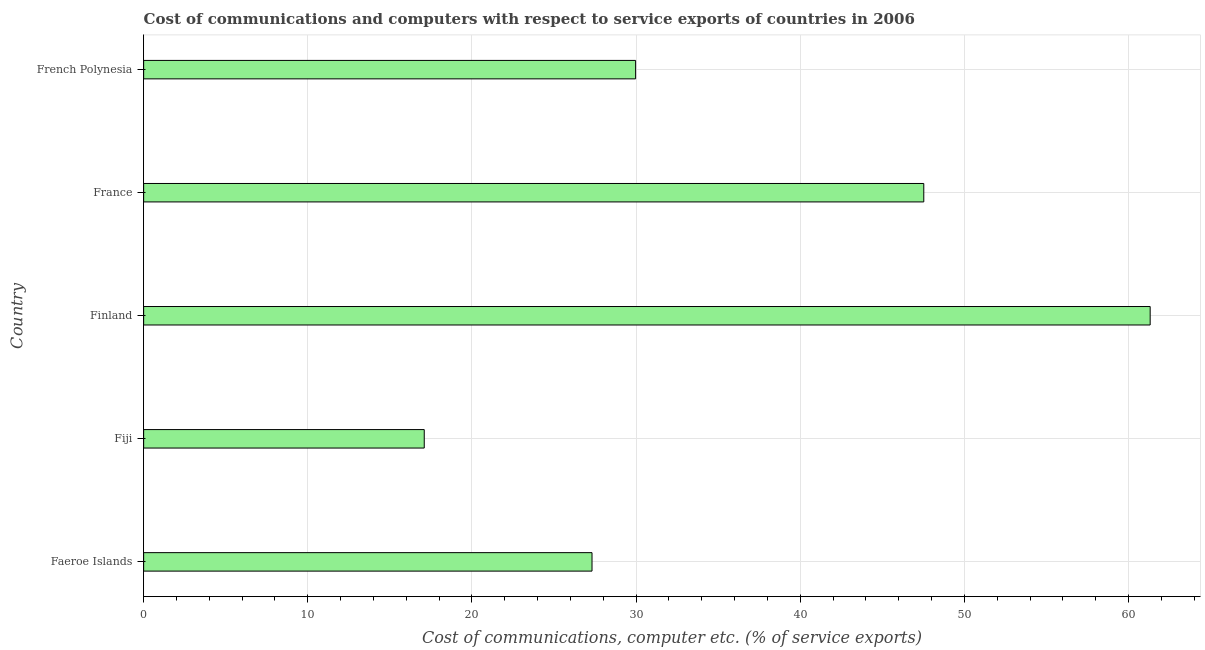Does the graph contain any zero values?
Your response must be concise. No. Does the graph contain grids?
Your response must be concise. Yes. What is the title of the graph?
Provide a succinct answer. Cost of communications and computers with respect to service exports of countries in 2006. What is the label or title of the X-axis?
Provide a succinct answer. Cost of communications, computer etc. (% of service exports). What is the cost of communications and computer in Fiji?
Your answer should be compact. 17.09. Across all countries, what is the maximum cost of communications and computer?
Make the answer very short. 61.32. Across all countries, what is the minimum cost of communications and computer?
Your answer should be compact. 17.09. In which country was the cost of communications and computer minimum?
Offer a terse response. Fiji. What is the sum of the cost of communications and computer?
Keep it short and to the point. 183.22. What is the difference between the cost of communications and computer in Fiji and French Polynesia?
Your answer should be very brief. -12.88. What is the average cost of communications and computer per country?
Provide a succinct answer. 36.65. What is the median cost of communications and computer?
Provide a short and direct response. 29.97. In how many countries, is the cost of communications and computer greater than 36 %?
Provide a short and direct response. 2. What is the ratio of the cost of communications and computer in Faeroe Islands to that in French Polynesia?
Make the answer very short. 0.91. Is the difference between the cost of communications and computer in Finland and France greater than the difference between any two countries?
Keep it short and to the point. No. What is the difference between the highest and the second highest cost of communications and computer?
Offer a very short reply. 13.79. Is the sum of the cost of communications and computer in Faeroe Islands and Finland greater than the maximum cost of communications and computer across all countries?
Your response must be concise. Yes. What is the difference between the highest and the lowest cost of communications and computer?
Offer a very short reply. 44.22. In how many countries, is the cost of communications and computer greater than the average cost of communications and computer taken over all countries?
Your response must be concise. 2. How many bars are there?
Keep it short and to the point. 5. How many countries are there in the graph?
Your answer should be very brief. 5. What is the difference between two consecutive major ticks on the X-axis?
Provide a succinct answer. 10. What is the Cost of communications, computer etc. (% of service exports) of Faeroe Islands?
Provide a succinct answer. 27.32. What is the Cost of communications, computer etc. (% of service exports) in Fiji?
Offer a very short reply. 17.09. What is the Cost of communications, computer etc. (% of service exports) of Finland?
Your answer should be very brief. 61.32. What is the Cost of communications, computer etc. (% of service exports) of France?
Your response must be concise. 47.53. What is the Cost of communications, computer etc. (% of service exports) of French Polynesia?
Your answer should be compact. 29.97. What is the difference between the Cost of communications, computer etc. (% of service exports) in Faeroe Islands and Fiji?
Make the answer very short. 10.22. What is the difference between the Cost of communications, computer etc. (% of service exports) in Faeroe Islands and Finland?
Give a very brief answer. -34. What is the difference between the Cost of communications, computer etc. (% of service exports) in Faeroe Islands and France?
Keep it short and to the point. -20.21. What is the difference between the Cost of communications, computer etc. (% of service exports) in Faeroe Islands and French Polynesia?
Make the answer very short. -2.66. What is the difference between the Cost of communications, computer etc. (% of service exports) in Fiji and Finland?
Make the answer very short. -44.22. What is the difference between the Cost of communications, computer etc. (% of service exports) in Fiji and France?
Your response must be concise. -30.43. What is the difference between the Cost of communications, computer etc. (% of service exports) in Fiji and French Polynesia?
Your answer should be very brief. -12.88. What is the difference between the Cost of communications, computer etc. (% of service exports) in Finland and France?
Provide a short and direct response. 13.79. What is the difference between the Cost of communications, computer etc. (% of service exports) in Finland and French Polynesia?
Offer a terse response. 31.35. What is the difference between the Cost of communications, computer etc. (% of service exports) in France and French Polynesia?
Ensure brevity in your answer.  17.56. What is the ratio of the Cost of communications, computer etc. (% of service exports) in Faeroe Islands to that in Fiji?
Your answer should be compact. 1.6. What is the ratio of the Cost of communications, computer etc. (% of service exports) in Faeroe Islands to that in Finland?
Provide a succinct answer. 0.45. What is the ratio of the Cost of communications, computer etc. (% of service exports) in Faeroe Islands to that in France?
Provide a short and direct response. 0.57. What is the ratio of the Cost of communications, computer etc. (% of service exports) in Faeroe Islands to that in French Polynesia?
Ensure brevity in your answer.  0.91. What is the ratio of the Cost of communications, computer etc. (% of service exports) in Fiji to that in Finland?
Make the answer very short. 0.28. What is the ratio of the Cost of communications, computer etc. (% of service exports) in Fiji to that in France?
Keep it short and to the point. 0.36. What is the ratio of the Cost of communications, computer etc. (% of service exports) in Fiji to that in French Polynesia?
Ensure brevity in your answer.  0.57. What is the ratio of the Cost of communications, computer etc. (% of service exports) in Finland to that in France?
Give a very brief answer. 1.29. What is the ratio of the Cost of communications, computer etc. (% of service exports) in Finland to that in French Polynesia?
Your response must be concise. 2.05. What is the ratio of the Cost of communications, computer etc. (% of service exports) in France to that in French Polynesia?
Offer a terse response. 1.59. 